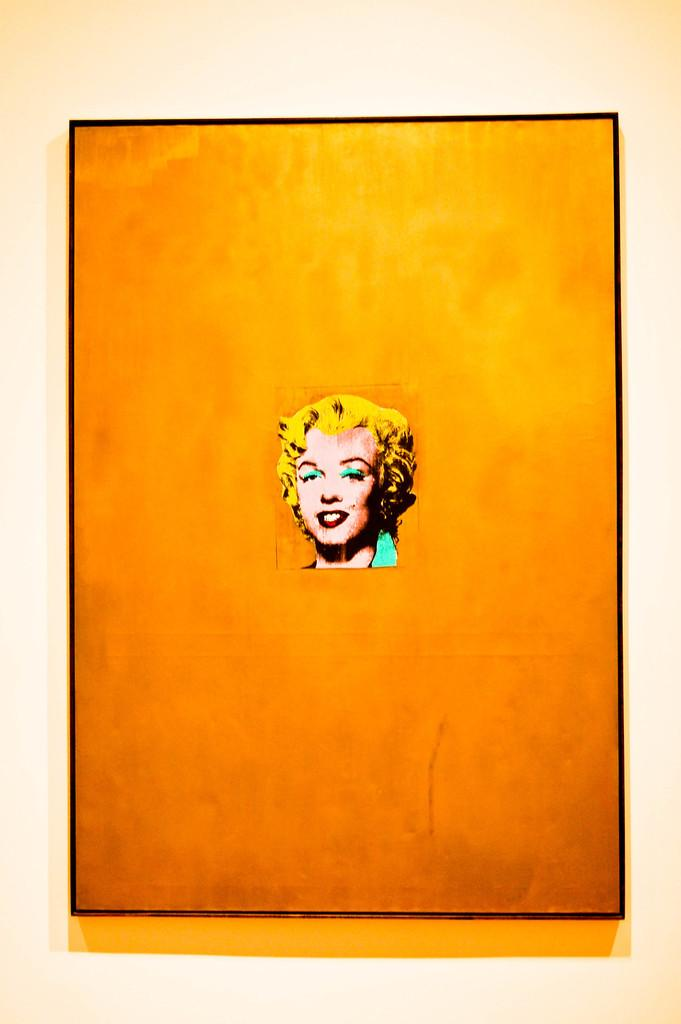What object is present in the image that typically holds a picture? There is a photo frame in the image. What can be seen inside the photo frame? The photo frame contains a picture of a person's face. What is the background of the picture inside the photo frame? The background of the picture is a plane. What type of plastic material can be seen floating in the sea in the image? There is no sea or plastic material present in the image; it features a photo frame with a picture of a person's face against a plane background. 